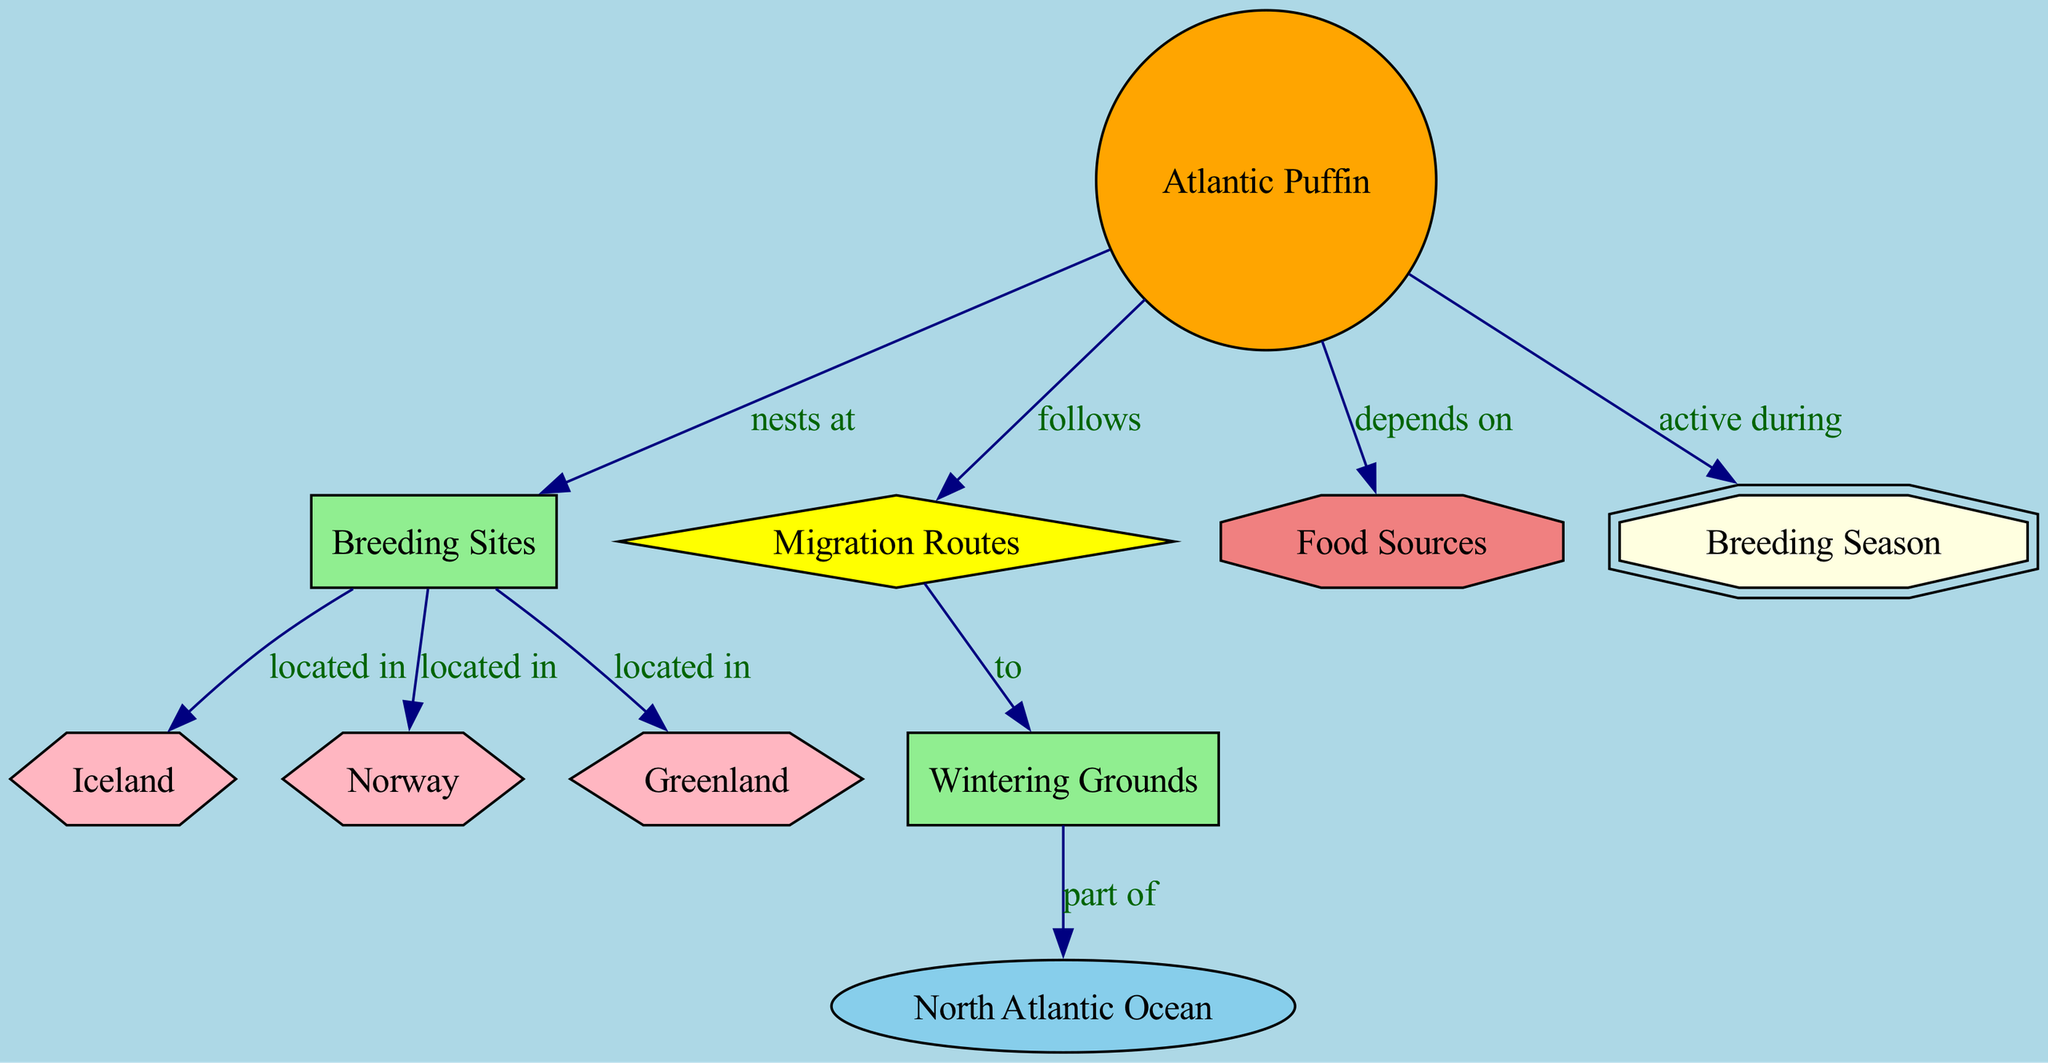What species is depicted in the diagram? The diagram features a single species, which is identified at the top and labeled as "Atlantic Puffin" in the nodes section.
Answer: Atlantic Puffin How many breeding sites are labeled in the diagram? The diagram has three nodes representing breeding sites located in different countries: Iceland, Norway, and Greenland. This can be confirmed by counting the edges that connect to these locations.
Answer: 3 What is the primary movement shown in the diagram? The movement indicated in the diagram connects the Atlantic Puffin to its migration routes. Under this relationship, there is an arrow showing that the puffin follows these routes, confirming the primary movement type.
Answer: follows Which country is not a wintering ground for the Atlantic Puffin? The diagram specifies two locations as wintering grounds (Greenland) but does not list one of the countries mentioned (Norway or Iceland) explicitly as a wintering ground, thus identifying one of these as not a wintering ground.
Answer: Norway What type of ecological factor do Atlantic Puffins depend on? According to the edges in the diagram, the Atlantic Puffins depend on "Food Sources" as their ecological factor. This is indicated by a direct connection from the species node to the ecological node.
Answer: Food Sources What do the migration routes lead to? The diagram shows an arrow from the migration routes leading to wintering grounds, indicating the destination of the migration path represented within the diagram.
Answer: to During which season are Atlantic Puffins active? The diagram specifies a relationship indicating a time for activity and it states “Breeding Season” as the timeframe during which the Atlantic Puffins are particularly active.
Answer: Breeding Season Which ocean is mentioned as part of the wintering grounds' geographic location? The edge that connects the wintering grounds directly points to the "North Atlantic Ocean," signifying its role as part of the habitat for the puffins during winter.
Answer: North Atlantic Ocean How many edges are present in the diagram? To determine the number of edges, one must count the connections represented between the nodes. The diagram shows a total of nine connections, or edges, linking different nodes together.
Answer: 9 What relationship connects the Atlantic Puffin to its breeding sites? The relationship is labeled "nests at," which indicates the method of connection between the Atlantic Puffin and its breeding sites in the diagram.
Answer: nests at 